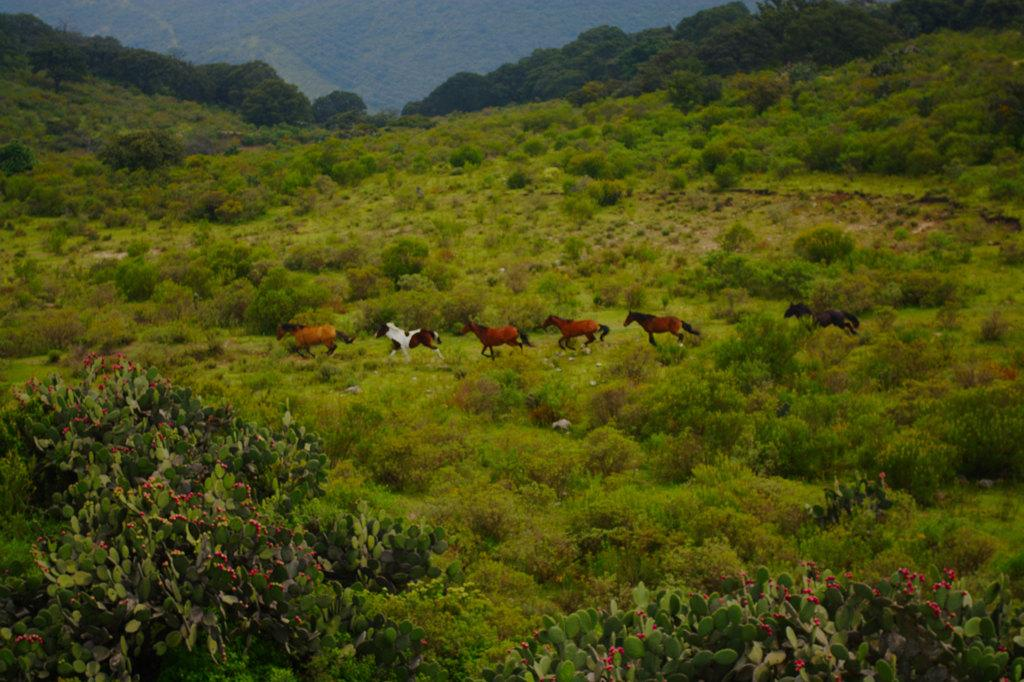What animals can be seen in the image? There are horses running in the image. What type of vegetation is present in the image? There are plants, trees, and flowers visible in the image. Can you describe the flowers in the image? The flowers are visible in the front of the image. Where is the harbor located in the image? There is no harbor present in the image. What type of pancake can be seen in the image? There is no pancake present in the image. 